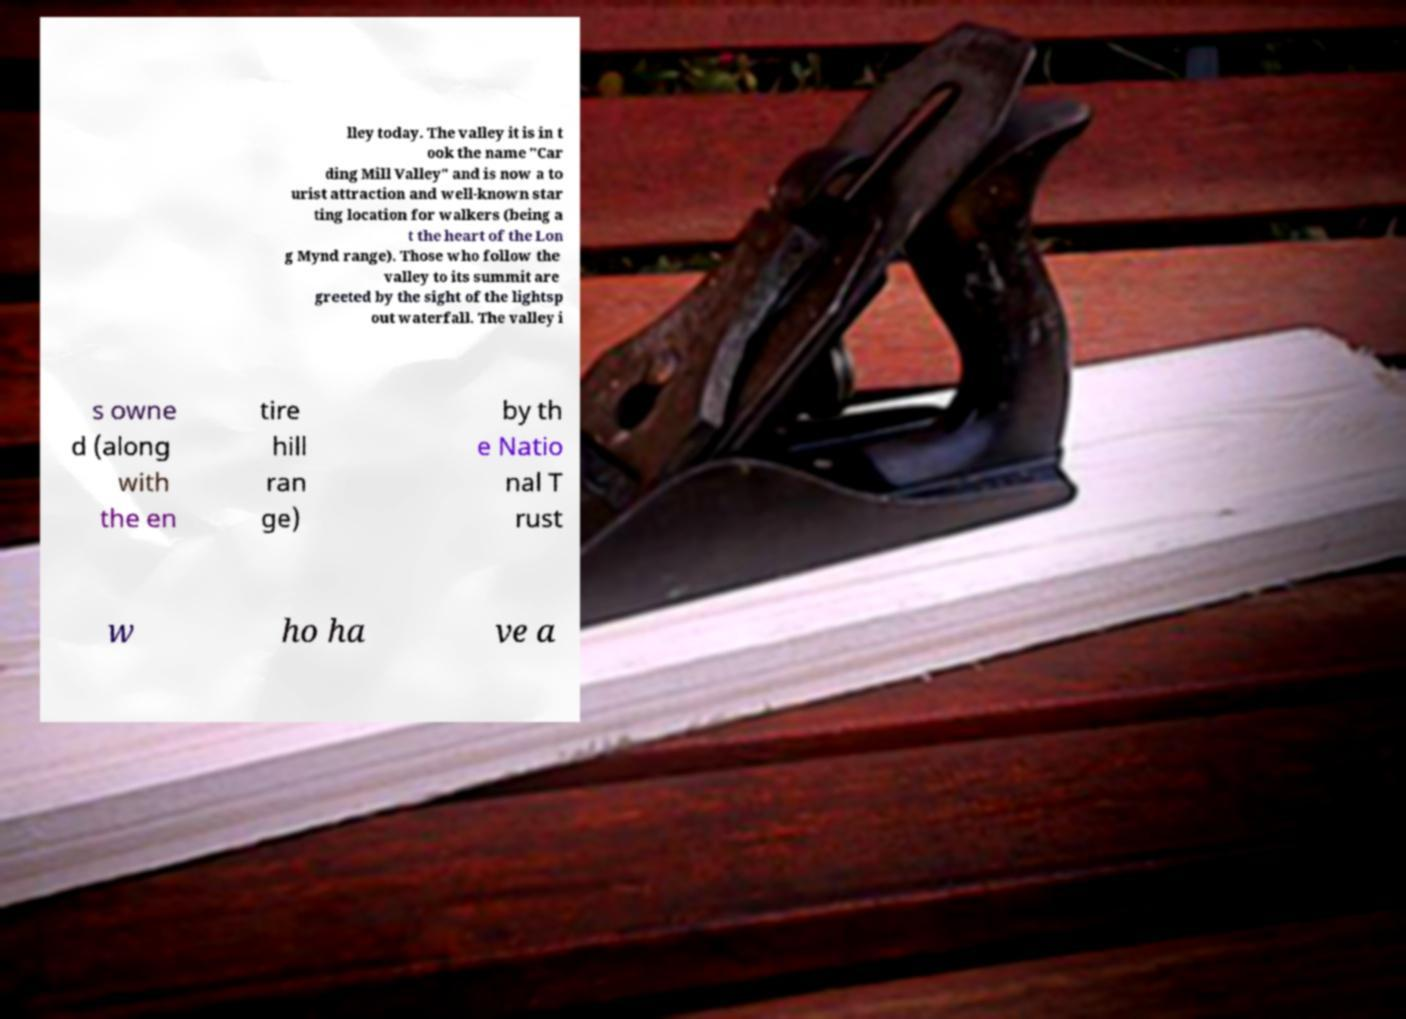Can you read and provide the text displayed in the image?This photo seems to have some interesting text. Can you extract and type it out for me? lley today. The valley it is in t ook the name "Car ding Mill Valley" and is now a to urist attraction and well-known star ting location for walkers (being a t the heart of the Lon g Mynd range). Those who follow the valley to its summit are greeted by the sight of the lightsp out waterfall. The valley i s owne d (along with the en tire hill ran ge) by th e Natio nal T rust w ho ha ve a 